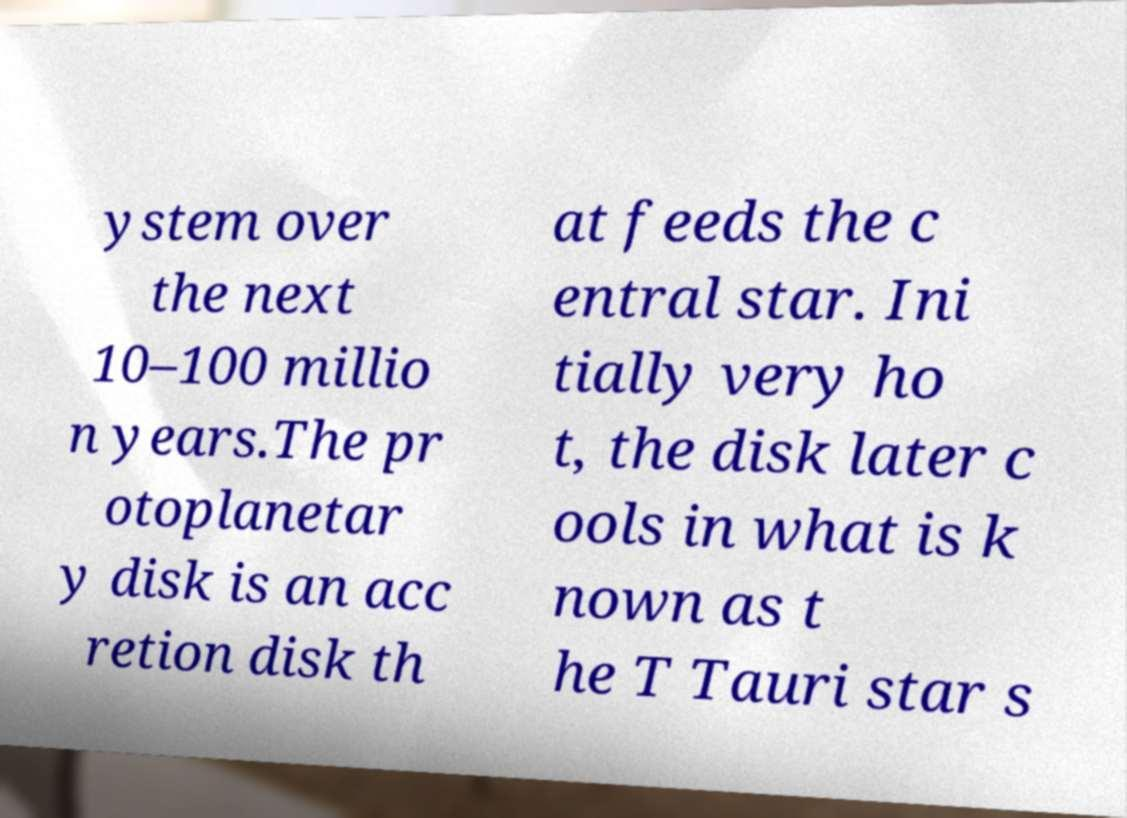There's text embedded in this image that I need extracted. Can you transcribe it verbatim? ystem over the next 10–100 millio n years.The pr otoplanetar y disk is an acc retion disk th at feeds the c entral star. Ini tially very ho t, the disk later c ools in what is k nown as t he T Tauri star s 